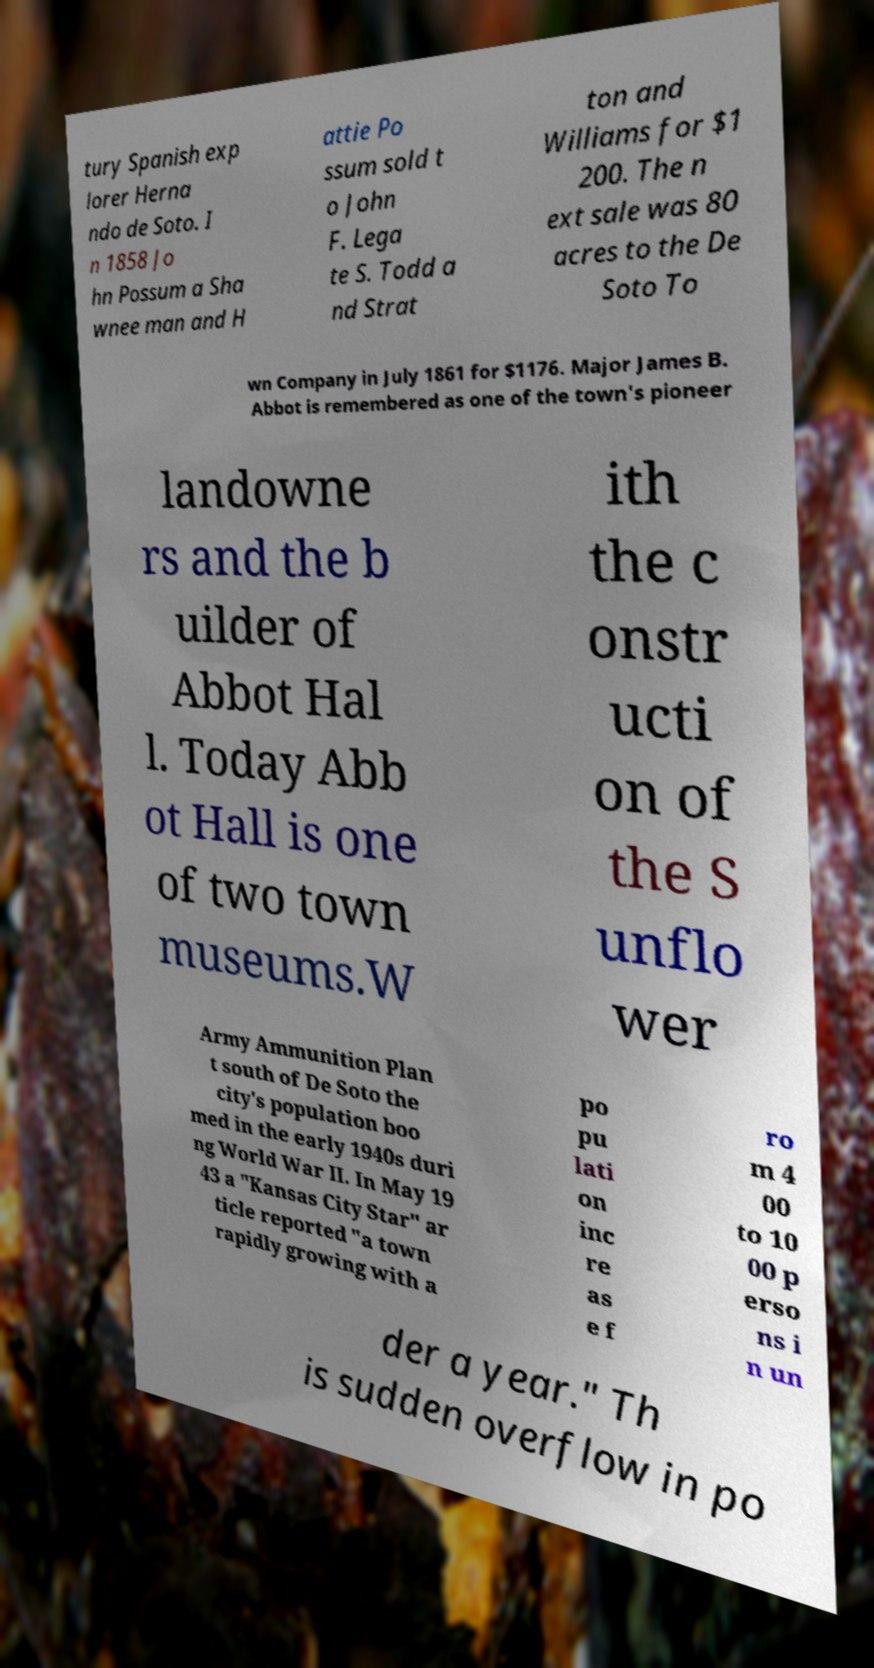Could you assist in decoding the text presented in this image and type it out clearly? tury Spanish exp lorer Herna ndo de Soto. I n 1858 Jo hn Possum a Sha wnee man and H attie Po ssum sold t o John F. Lega te S. Todd a nd Strat ton and Williams for $1 200. The n ext sale was 80 acres to the De Soto To wn Company in July 1861 for $1176. Major James B. Abbot is remembered as one of the town's pioneer landowne rs and the b uilder of Abbot Hal l. Today Abb ot Hall is one of two town museums.W ith the c onstr ucti on of the S unflo wer Army Ammunition Plan t south of De Soto the city's population boo med in the early 1940s duri ng World War II. In May 19 43 a "Kansas City Star" ar ticle reported "a town rapidly growing with a po pu lati on inc re as e f ro m 4 00 to 10 00 p erso ns i n un der a year." Th is sudden overflow in po 